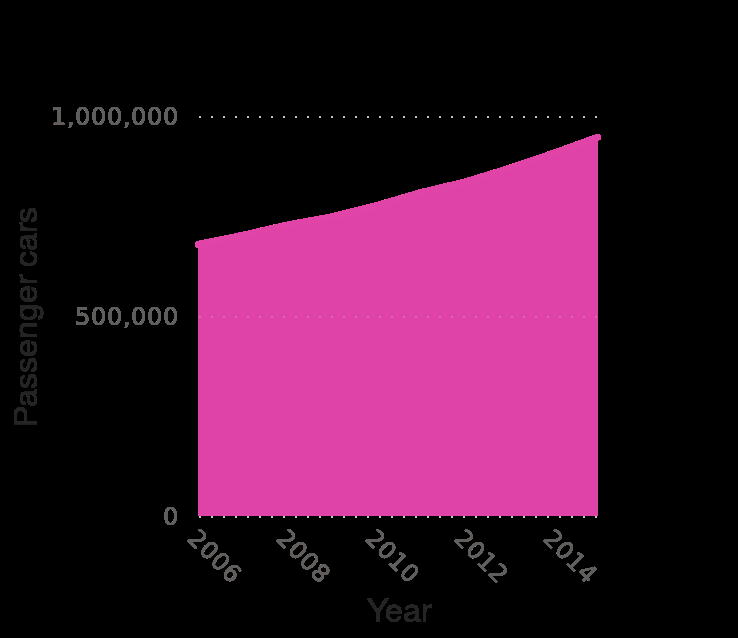<image>
What is the volume of users like? The volume of users is consistently high. What is the range of years covered in the area chart? The area chart covers the years from 2006 to 2015. 